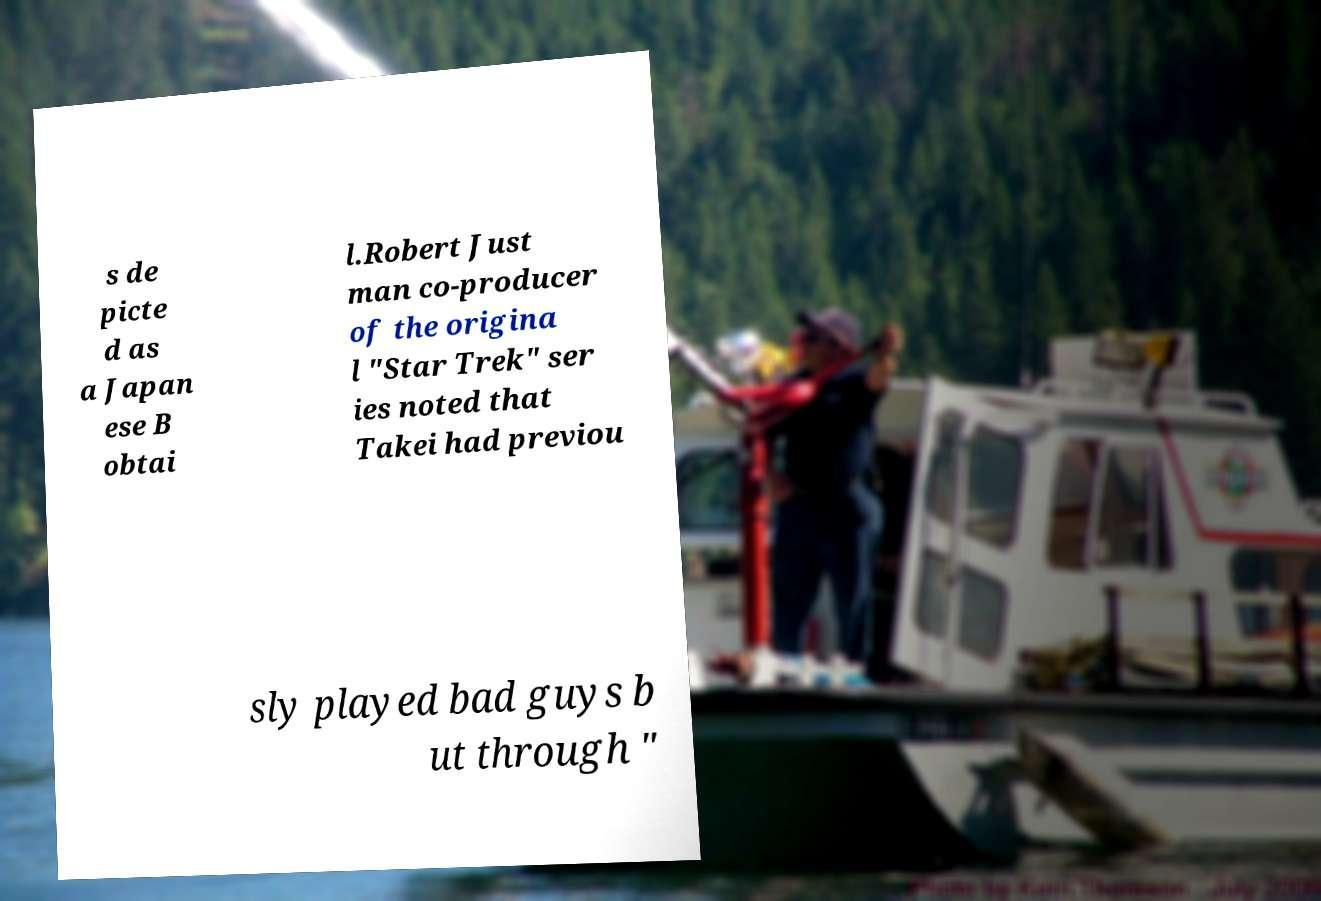Can you accurately transcribe the text from the provided image for me? s de picte d as a Japan ese B obtai l.Robert Just man co-producer of the origina l "Star Trek" ser ies noted that Takei had previou sly played bad guys b ut through " 